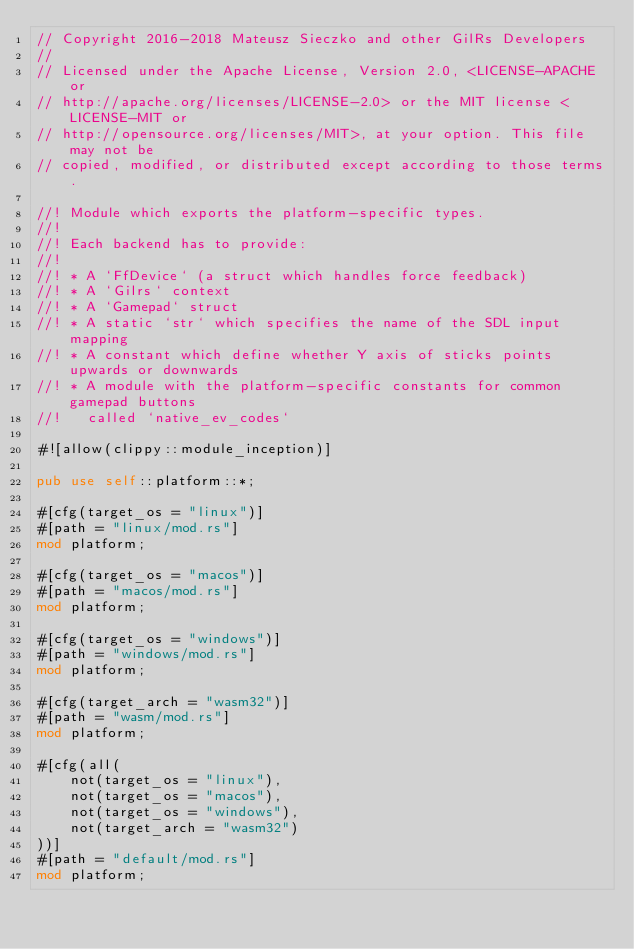<code> <loc_0><loc_0><loc_500><loc_500><_Rust_>// Copyright 2016-2018 Mateusz Sieczko and other GilRs Developers
//
// Licensed under the Apache License, Version 2.0, <LICENSE-APACHE or
// http://apache.org/licenses/LICENSE-2.0> or the MIT license <LICENSE-MIT or
// http://opensource.org/licenses/MIT>, at your option. This file may not be
// copied, modified, or distributed except according to those terms.

//! Module which exports the platform-specific types.
//!
//! Each backend has to provide:
//!
//! * A `FfDevice` (a struct which handles force feedback)
//! * A `Gilrs` context
//! * A `Gamepad` struct
//! * A static `str` which specifies the name of the SDL input mapping
//! * A constant which define whether Y axis of sticks points upwards or downwards
//! * A module with the platform-specific constants for common gamepad buttons
//!   called `native_ev_codes`

#![allow(clippy::module_inception)]

pub use self::platform::*;

#[cfg(target_os = "linux")]
#[path = "linux/mod.rs"]
mod platform;

#[cfg(target_os = "macos")]
#[path = "macos/mod.rs"]
mod platform;

#[cfg(target_os = "windows")]
#[path = "windows/mod.rs"]
mod platform;

#[cfg(target_arch = "wasm32")]
#[path = "wasm/mod.rs"]
mod platform;

#[cfg(all(
    not(target_os = "linux"),
    not(target_os = "macos"),
    not(target_os = "windows"),
    not(target_arch = "wasm32")
))]
#[path = "default/mod.rs"]
mod platform;
</code> 